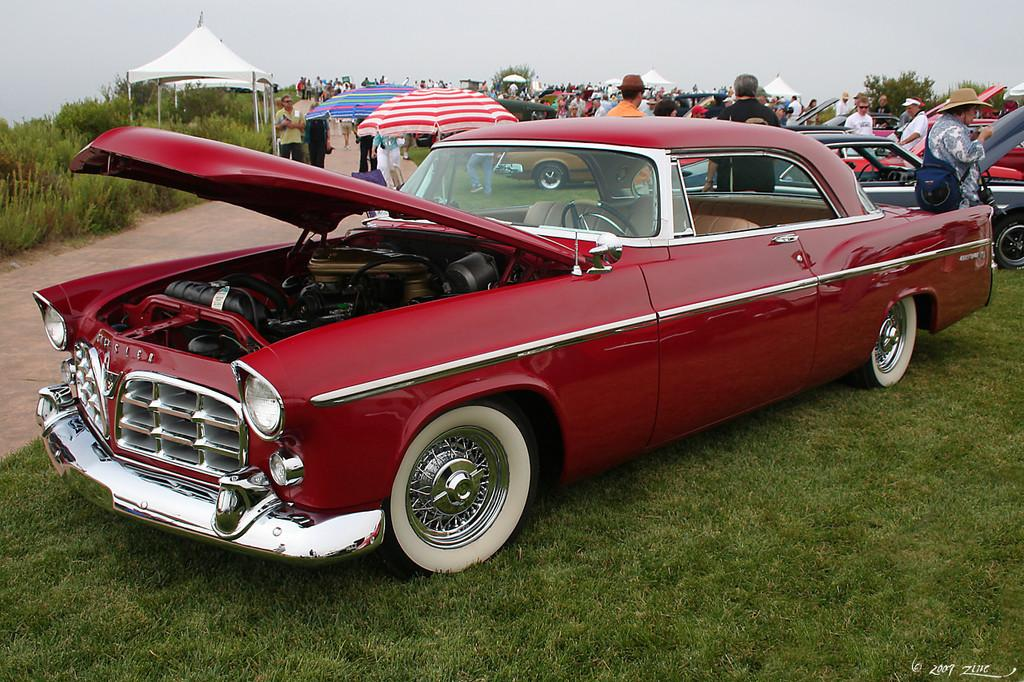What types of objects are present in the image? There are vehicles, umbrellas, tents, and plants in the image. What can be seen in the sky in the image? The sky is visible in the image. Are there any living beings in the image? Yes, there are people in the image. What type of lamp is hanging from the tree in the image? There is no lamp present in the image; it features vehicles, umbrellas, tents, plants, the sky, and people. What kind of nut is being cracked by the laborer in the image? There is no laborer or nut present in the image. 